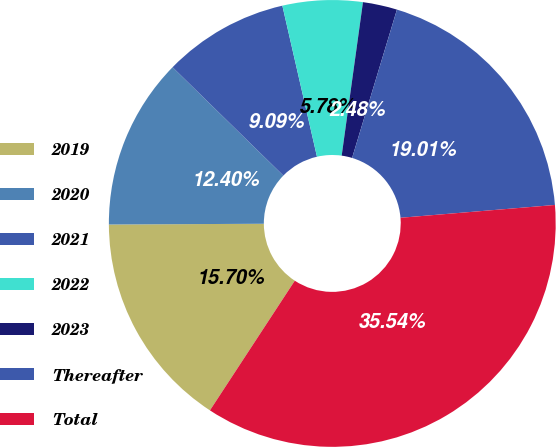Convert chart to OTSL. <chart><loc_0><loc_0><loc_500><loc_500><pie_chart><fcel>2019<fcel>2020<fcel>2021<fcel>2022<fcel>2023<fcel>Thereafter<fcel>Total<nl><fcel>15.7%<fcel>12.4%<fcel>9.09%<fcel>5.78%<fcel>2.48%<fcel>19.01%<fcel>35.54%<nl></chart> 